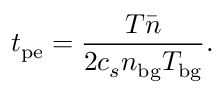<formula> <loc_0><loc_0><loc_500><loc_500>t _ { p e } = \frac { T \bar { n } } { 2 c _ { s } n _ { b g } T _ { b g } } .</formula> 